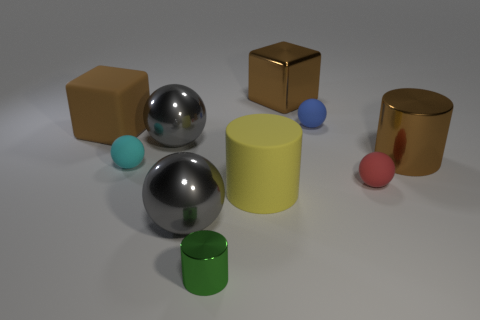Subtract 1 spheres. How many spheres are left? 4 Subtract all cylinders. How many objects are left? 7 Subtract 0 blue cubes. How many objects are left? 10 Subtract all small objects. Subtract all large matte objects. How many objects are left? 4 Add 7 small balls. How many small balls are left? 10 Add 9 small green cylinders. How many small green cylinders exist? 10 